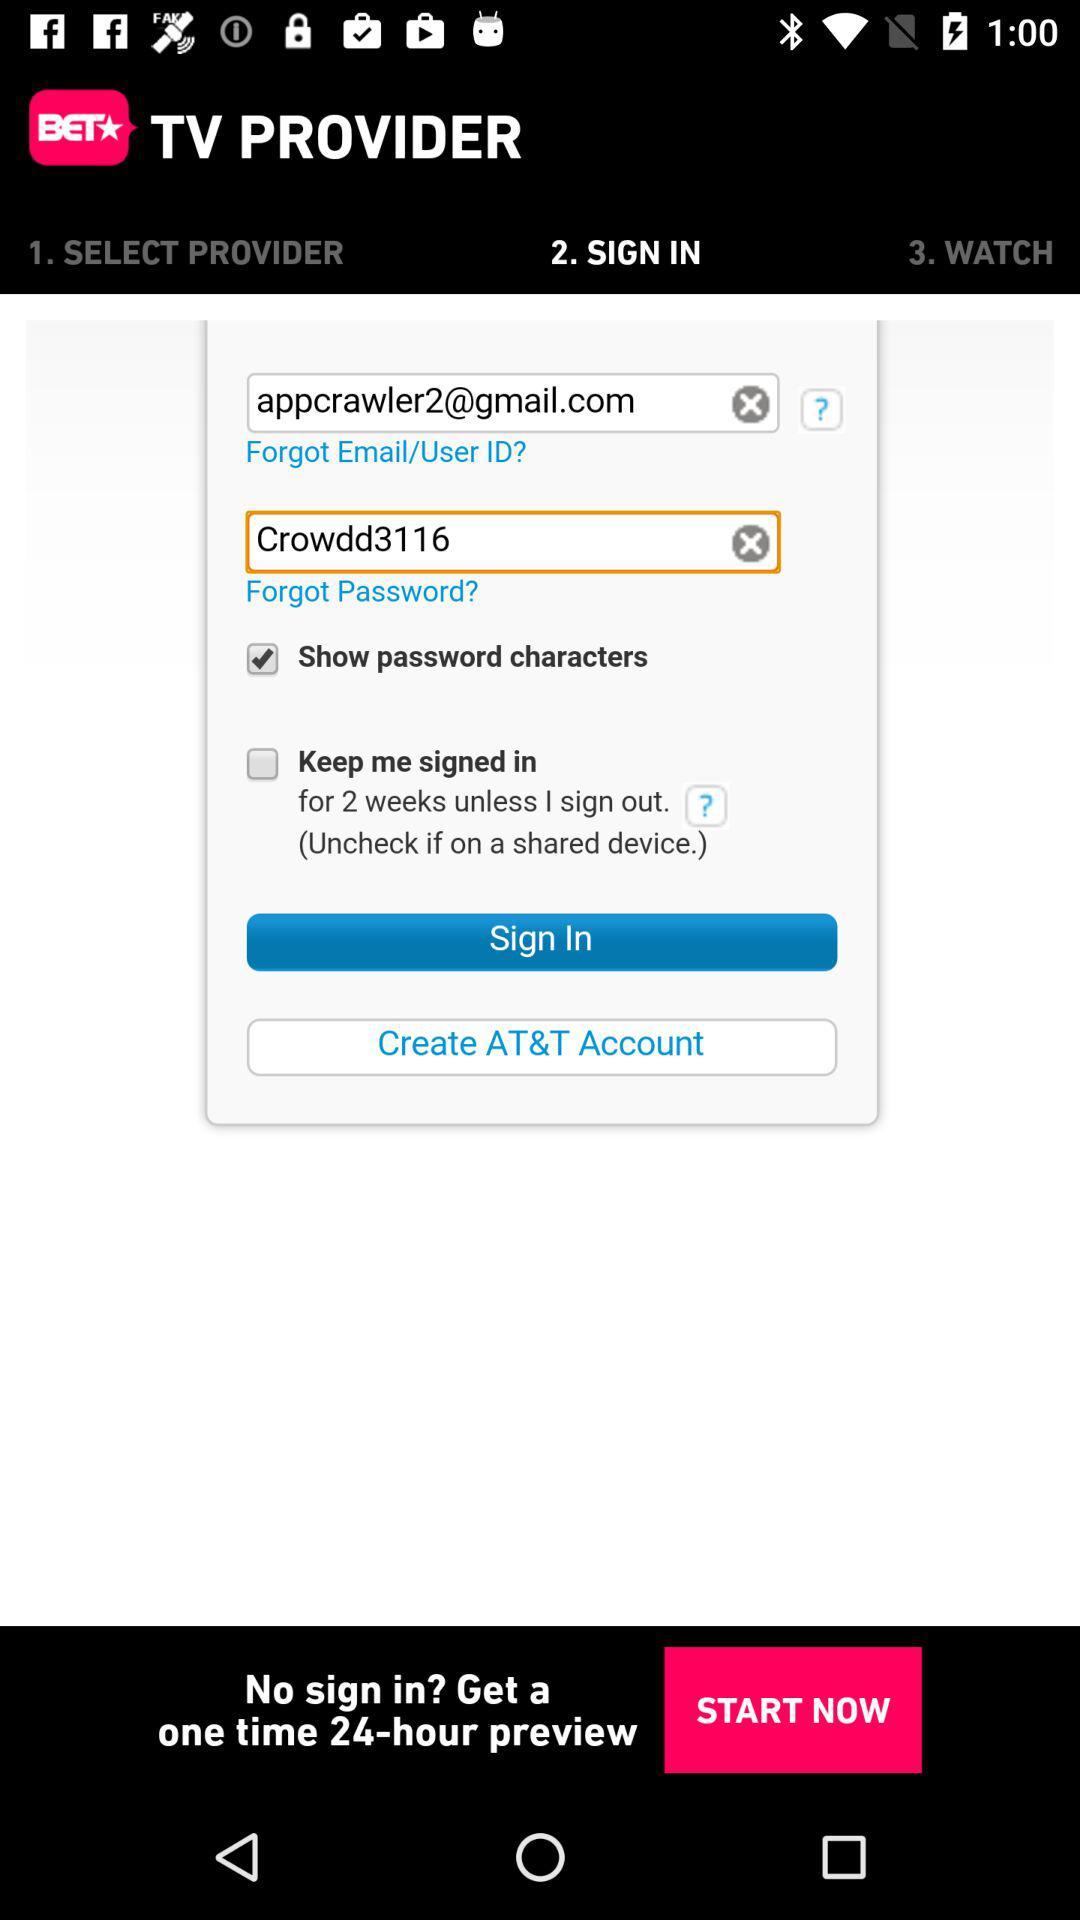What is the password? The password is "Crowdd3116". 